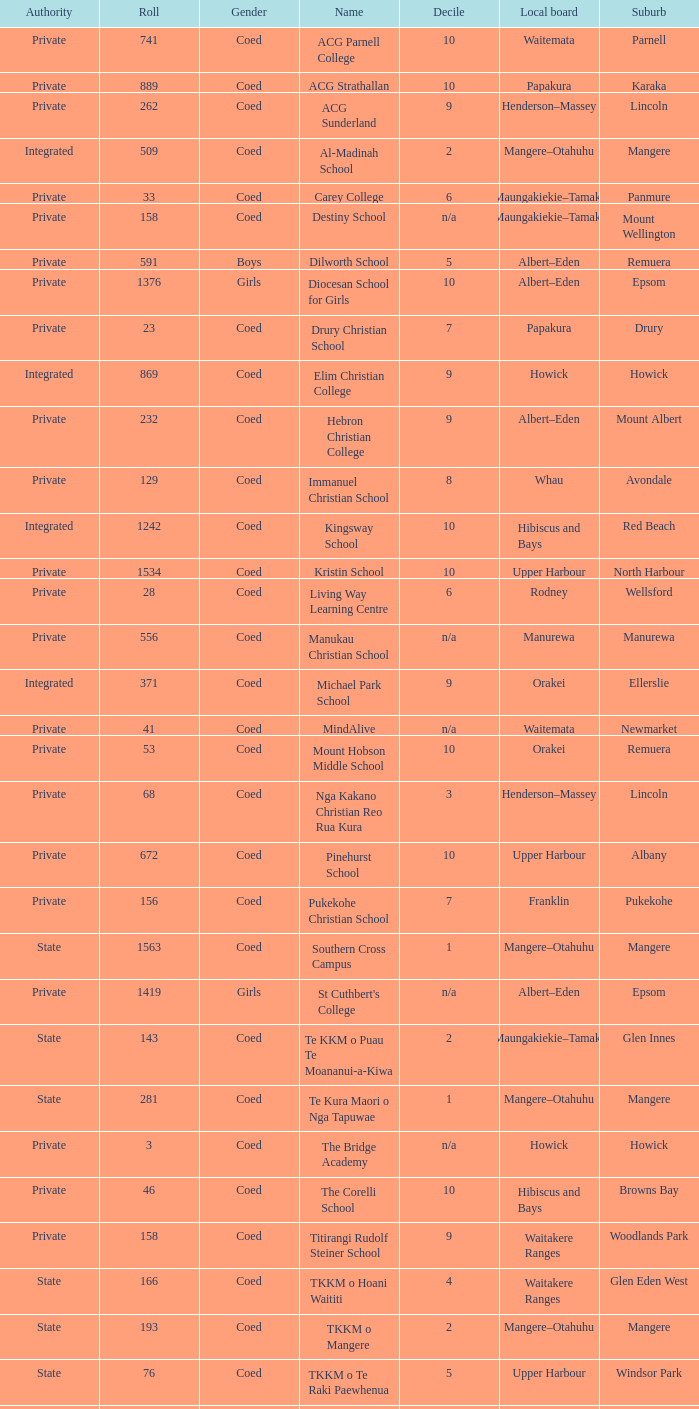What is the name of the suburb with a roll of 741? Parnell. 